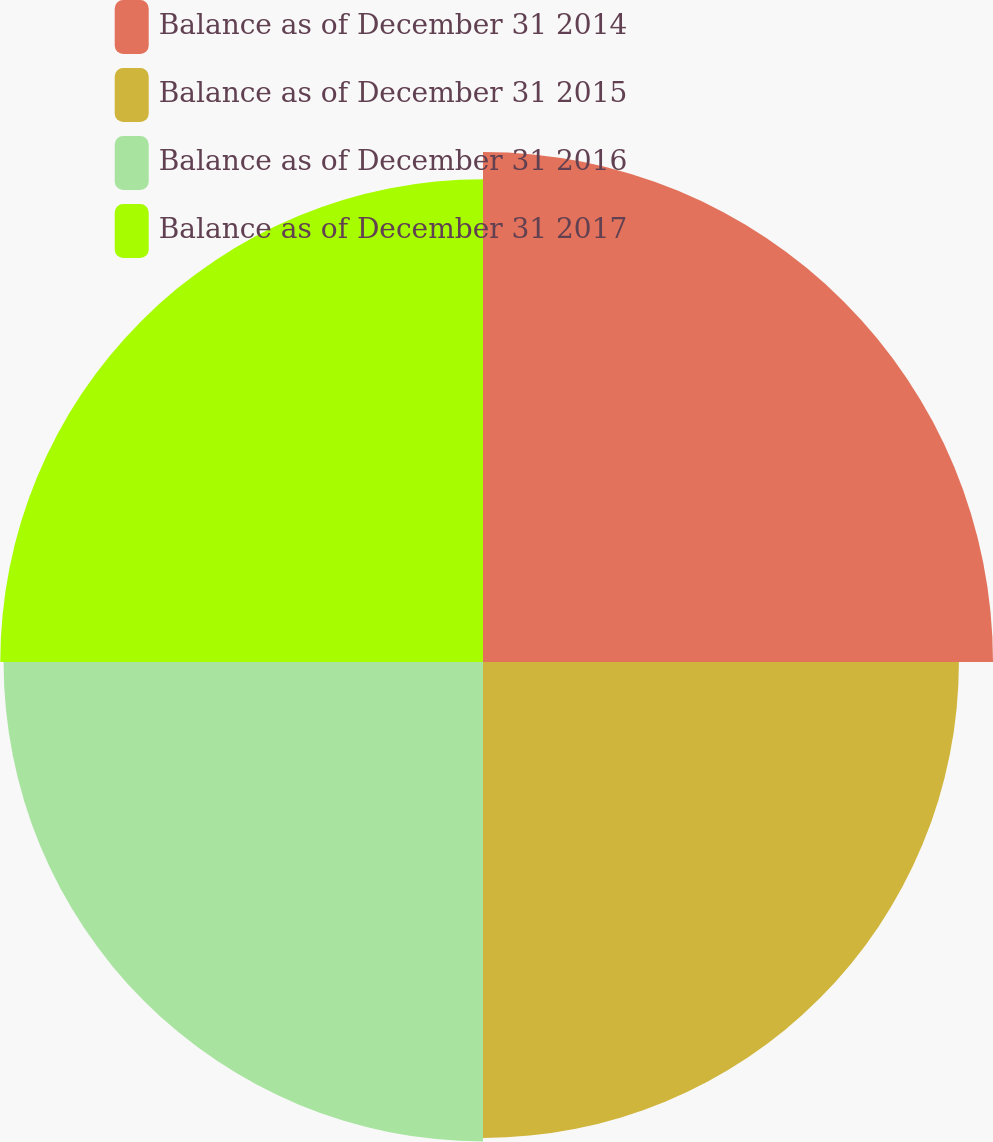Convert chart. <chart><loc_0><loc_0><loc_500><loc_500><pie_chart><fcel>Balance as of December 31 2014<fcel>Balance as of December 31 2015<fcel>Balance as of December 31 2016<fcel>Balance as of December 31 2017<nl><fcel>26.18%<fcel>24.43%<fcel>24.61%<fcel>24.78%<nl></chart> 